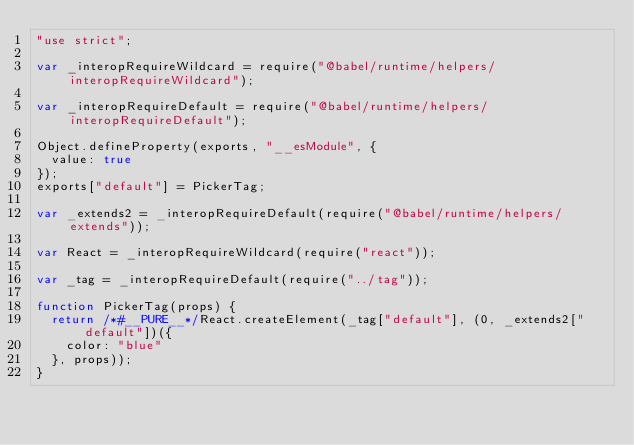<code> <loc_0><loc_0><loc_500><loc_500><_JavaScript_>"use strict";

var _interopRequireWildcard = require("@babel/runtime/helpers/interopRequireWildcard");

var _interopRequireDefault = require("@babel/runtime/helpers/interopRequireDefault");

Object.defineProperty(exports, "__esModule", {
  value: true
});
exports["default"] = PickerTag;

var _extends2 = _interopRequireDefault(require("@babel/runtime/helpers/extends"));

var React = _interopRequireWildcard(require("react"));

var _tag = _interopRequireDefault(require("../tag"));

function PickerTag(props) {
  return /*#__PURE__*/React.createElement(_tag["default"], (0, _extends2["default"])({
    color: "blue"
  }, props));
}</code> 